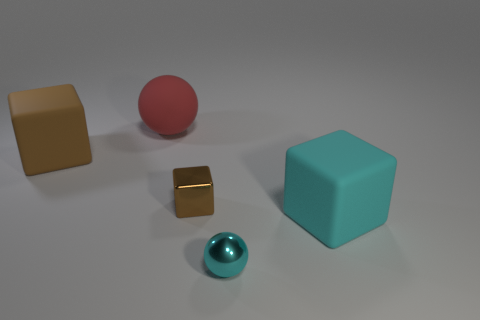Subtract all rubber blocks. How many blocks are left? 1 Add 2 big cylinders. How many objects exist? 7 Subtract all green balls. How many brown cubes are left? 2 Subtract 1 balls. How many balls are left? 1 Subtract all blocks. How many objects are left? 2 Add 2 brown shiny cubes. How many brown shiny cubes exist? 3 Subtract 2 brown cubes. How many objects are left? 3 Subtract all blue cubes. Subtract all brown balls. How many cubes are left? 3 Subtract all tiny gray shiny blocks. Subtract all balls. How many objects are left? 3 Add 5 small cyan metal balls. How many small cyan metal balls are left? 6 